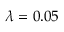<formula> <loc_0><loc_0><loc_500><loc_500>\lambda = 0 . 0 5</formula> 